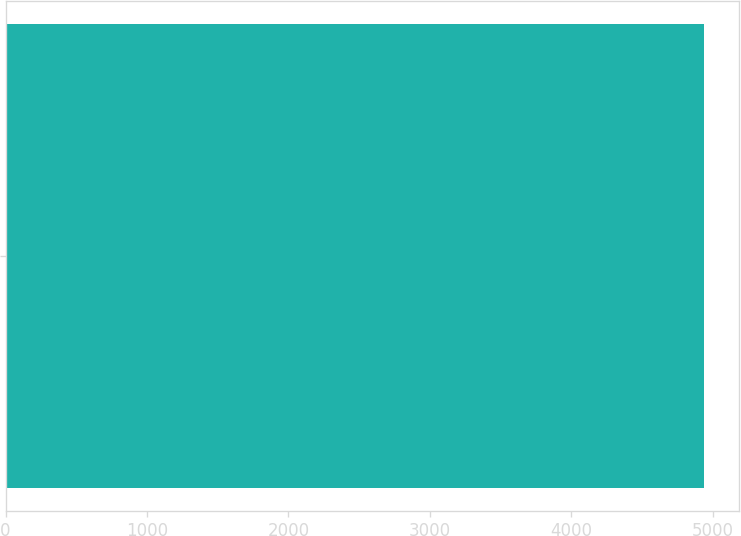<chart> <loc_0><loc_0><loc_500><loc_500><bar_chart><ecel><nl><fcel>4939<nl></chart> 